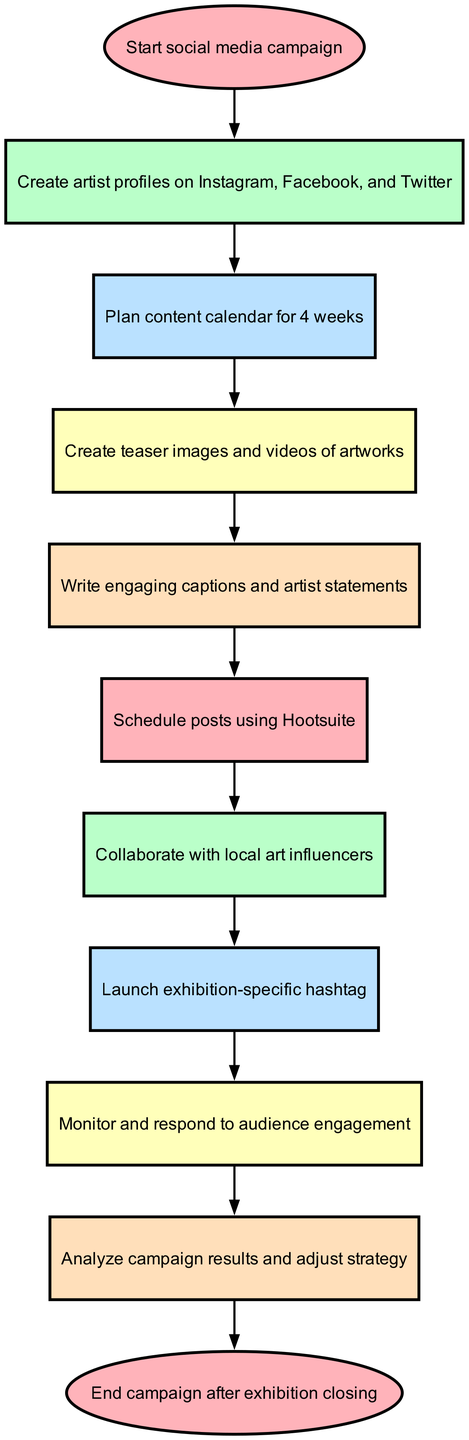What is the first step in the social media campaign? The first step is indicated by the "start" node, which states "Start social media campaign." This is where the process begins.
Answer: Start social media campaign How many main tasks are listed in the campaign flowchart? By counting the elements represented as nodes (excluding the start and end nodes), there are eight main tasks in the flowchart.
Answer: Eight What comes directly after planning the content calendar? After "plan content," the next step in the flowchart is "create visuals," indicating that visual content creation follows planning.
Answer: Create teaser images and videos of artworks Which node represents the action of interacting with the audience? The "monitor engagement" node represents the action of interacting with the audience, where the campaign's success in engaging the audience is evaluated.
Answer: Monitor and respond to audience engagement What action is taken after writing engaging captions? Following the "write posts" node, the next action specified in the flowchart is to "schedule posts," which is the step of organizing when the content will be published.
Answer: Schedule posts using Hootsuite Which two stages are linked directly by the "launch hashtag"? The "launch hashtag" node connects "collaborate with local art influencers" and "monitor engagement," indicating that these two actions are sequentially related.
Answer: Collaborate with local art influencers and monitor engagement What is the final action represented in this flowchart? The last node, labeled "end," signifies the final action of the campaign, which occurs after the exhibition closing. This indicates the campaign's completion.
Answer: End campaign after exhibition closing How do you proceed after analyzing the campaign results? After "analyze results," there is no subsequent action indicated, as it leads directly to the "end" node, which signifies the completion of the campaign process without further steps.
Answer: End campaign after exhibition closing 